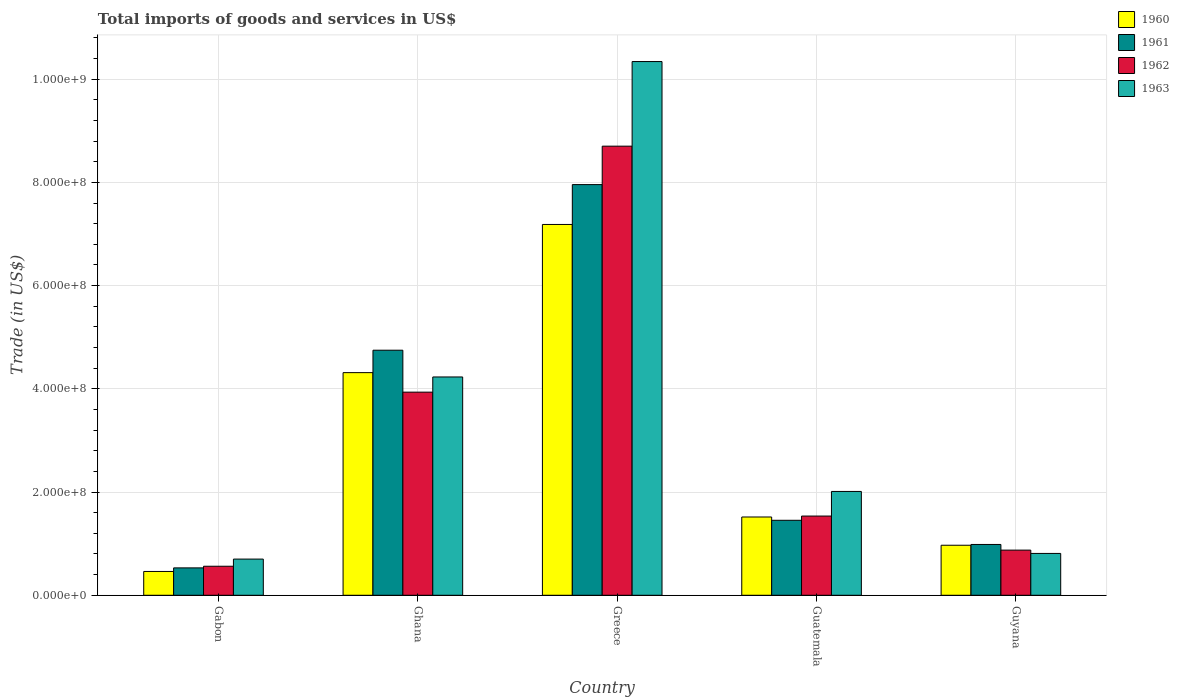Are the number of bars on each tick of the X-axis equal?
Make the answer very short. Yes. How many bars are there on the 1st tick from the left?
Your response must be concise. 4. What is the label of the 1st group of bars from the left?
Give a very brief answer. Gabon. In how many cases, is the number of bars for a given country not equal to the number of legend labels?
Provide a succinct answer. 0. What is the total imports of goods and services in 1960 in Greece?
Your answer should be very brief. 7.19e+08. Across all countries, what is the maximum total imports of goods and services in 1960?
Keep it short and to the point. 7.19e+08. Across all countries, what is the minimum total imports of goods and services in 1961?
Your answer should be very brief. 5.31e+07. In which country was the total imports of goods and services in 1961 minimum?
Keep it short and to the point. Gabon. What is the total total imports of goods and services in 1961 in the graph?
Provide a succinct answer. 1.57e+09. What is the difference between the total imports of goods and services in 1963 in Guatemala and that in Guyana?
Your response must be concise. 1.20e+08. What is the difference between the total imports of goods and services in 1962 in Guatemala and the total imports of goods and services in 1963 in Gabon?
Make the answer very short. 8.34e+07. What is the average total imports of goods and services in 1963 per country?
Your response must be concise. 3.62e+08. What is the difference between the total imports of goods and services of/in 1961 and total imports of goods and services of/in 1962 in Gabon?
Make the answer very short. -3.16e+06. What is the ratio of the total imports of goods and services in 1962 in Greece to that in Guatemala?
Give a very brief answer. 5.67. What is the difference between the highest and the second highest total imports of goods and services in 1960?
Offer a very short reply. -2.80e+08. What is the difference between the highest and the lowest total imports of goods and services in 1962?
Keep it short and to the point. 8.14e+08. Is it the case that in every country, the sum of the total imports of goods and services in 1960 and total imports of goods and services in 1961 is greater than the sum of total imports of goods and services in 1962 and total imports of goods and services in 1963?
Provide a succinct answer. No. What does the 3rd bar from the left in Ghana represents?
Your answer should be very brief. 1962. What does the 3rd bar from the right in Ghana represents?
Provide a succinct answer. 1961. Are all the bars in the graph horizontal?
Give a very brief answer. No. What is the difference between two consecutive major ticks on the Y-axis?
Make the answer very short. 2.00e+08. Does the graph contain any zero values?
Offer a very short reply. No. Where does the legend appear in the graph?
Make the answer very short. Top right. How many legend labels are there?
Provide a short and direct response. 4. How are the legend labels stacked?
Provide a short and direct response. Vertical. What is the title of the graph?
Offer a terse response. Total imports of goods and services in US$. What is the label or title of the X-axis?
Make the answer very short. Country. What is the label or title of the Y-axis?
Offer a terse response. Trade (in US$). What is the Trade (in US$) in 1960 in Gabon?
Give a very brief answer. 4.62e+07. What is the Trade (in US$) of 1961 in Gabon?
Keep it short and to the point. 5.31e+07. What is the Trade (in US$) of 1962 in Gabon?
Keep it short and to the point. 5.62e+07. What is the Trade (in US$) in 1963 in Gabon?
Offer a very short reply. 7.01e+07. What is the Trade (in US$) in 1960 in Ghana?
Offer a very short reply. 4.31e+08. What is the Trade (in US$) in 1961 in Ghana?
Your response must be concise. 4.75e+08. What is the Trade (in US$) of 1962 in Ghana?
Your response must be concise. 3.94e+08. What is the Trade (in US$) of 1963 in Ghana?
Offer a very short reply. 4.23e+08. What is the Trade (in US$) in 1960 in Greece?
Give a very brief answer. 7.19e+08. What is the Trade (in US$) of 1961 in Greece?
Make the answer very short. 7.96e+08. What is the Trade (in US$) of 1962 in Greece?
Offer a terse response. 8.70e+08. What is the Trade (in US$) in 1963 in Greece?
Your answer should be compact. 1.03e+09. What is the Trade (in US$) in 1960 in Guatemala?
Your response must be concise. 1.52e+08. What is the Trade (in US$) of 1961 in Guatemala?
Your response must be concise. 1.45e+08. What is the Trade (in US$) of 1962 in Guatemala?
Provide a succinct answer. 1.54e+08. What is the Trade (in US$) in 1963 in Guatemala?
Your response must be concise. 2.01e+08. What is the Trade (in US$) in 1960 in Guyana?
Provide a short and direct response. 9.69e+07. What is the Trade (in US$) of 1961 in Guyana?
Give a very brief answer. 9.85e+07. What is the Trade (in US$) in 1962 in Guyana?
Make the answer very short. 8.75e+07. What is the Trade (in US$) of 1963 in Guyana?
Give a very brief answer. 8.11e+07. Across all countries, what is the maximum Trade (in US$) of 1960?
Offer a very short reply. 7.19e+08. Across all countries, what is the maximum Trade (in US$) of 1961?
Provide a short and direct response. 7.96e+08. Across all countries, what is the maximum Trade (in US$) in 1962?
Provide a short and direct response. 8.70e+08. Across all countries, what is the maximum Trade (in US$) of 1963?
Keep it short and to the point. 1.03e+09. Across all countries, what is the minimum Trade (in US$) in 1960?
Keep it short and to the point. 4.62e+07. Across all countries, what is the minimum Trade (in US$) of 1961?
Your answer should be compact. 5.31e+07. Across all countries, what is the minimum Trade (in US$) in 1962?
Ensure brevity in your answer.  5.62e+07. Across all countries, what is the minimum Trade (in US$) in 1963?
Your answer should be very brief. 7.01e+07. What is the total Trade (in US$) in 1960 in the graph?
Keep it short and to the point. 1.44e+09. What is the total Trade (in US$) of 1961 in the graph?
Ensure brevity in your answer.  1.57e+09. What is the total Trade (in US$) of 1962 in the graph?
Make the answer very short. 1.56e+09. What is the total Trade (in US$) of 1963 in the graph?
Your answer should be very brief. 1.81e+09. What is the difference between the Trade (in US$) in 1960 in Gabon and that in Ghana?
Your response must be concise. -3.85e+08. What is the difference between the Trade (in US$) of 1961 in Gabon and that in Ghana?
Offer a terse response. -4.22e+08. What is the difference between the Trade (in US$) of 1962 in Gabon and that in Ghana?
Offer a terse response. -3.37e+08. What is the difference between the Trade (in US$) of 1963 in Gabon and that in Ghana?
Keep it short and to the point. -3.53e+08. What is the difference between the Trade (in US$) of 1960 in Gabon and that in Greece?
Provide a short and direct response. -6.72e+08. What is the difference between the Trade (in US$) of 1961 in Gabon and that in Greece?
Your answer should be compact. -7.43e+08. What is the difference between the Trade (in US$) in 1962 in Gabon and that in Greece?
Ensure brevity in your answer.  -8.14e+08. What is the difference between the Trade (in US$) of 1963 in Gabon and that in Greece?
Give a very brief answer. -9.64e+08. What is the difference between the Trade (in US$) of 1960 in Gabon and that in Guatemala?
Provide a succinct answer. -1.06e+08. What is the difference between the Trade (in US$) in 1961 in Gabon and that in Guatemala?
Ensure brevity in your answer.  -9.22e+07. What is the difference between the Trade (in US$) of 1962 in Gabon and that in Guatemala?
Provide a short and direct response. -9.73e+07. What is the difference between the Trade (in US$) in 1963 in Gabon and that in Guatemala?
Your response must be concise. -1.31e+08. What is the difference between the Trade (in US$) of 1960 in Gabon and that in Guyana?
Provide a succinct answer. -5.08e+07. What is the difference between the Trade (in US$) in 1961 in Gabon and that in Guyana?
Keep it short and to the point. -4.54e+07. What is the difference between the Trade (in US$) in 1962 in Gabon and that in Guyana?
Ensure brevity in your answer.  -3.13e+07. What is the difference between the Trade (in US$) of 1963 in Gabon and that in Guyana?
Provide a short and direct response. -1.10e+07. What is the difference between the Trade (in US$) in 1960 in Ghana and that in Greece?
Ensure brevity in your answer.  -2.87e+08. What is the difference between the Trade (in US$) of 1961 in Ghana and that in Greece?
Keep it short and to the point. -3.21e+08. What is the difference between the Trade (in US$) in 1962 in Ghana and that in Greece?
Keep it short and to the point. -4.77e+08. What is the difference between the Trade (in US$) of 1963 in Ghana and that in Greece?
Give a very brief answer. -6.11e+08. What is the difference between the Trade (in US$) in 1960 in Ghana and that in Guatemala?
Ensure brevity in your answer.  2.80e+08. What is the difference between the Trade (in US$) of 1961 in Ghana and that in Guatemala?
Keep it short and to the point. 3.30e+08. What is the difference between the Trade (in US$) in 1962 in Ghana and that in Guatemala?
Give a very brief answer. 2.40e+08. What is the difference between the Trade (in US$) of 1963 in Ghana and that in Guatemala?
Your answer should be compact. 2.22e+08. What is the difference between the Trade (in US$) of 1960 in Ghana and that in Guyana?
Ensure brevity in your answer.  3.34e+08. What is the difference between the Trade (in US$) in 1961 in Ghana and that in Guyana?
Your answer should be compact. 3.76e+08. What is the difference between the Trade (in US$) in 1962 in Ghana and that in Guyana?
Your response must be concise. 3.06e+08. What is the difference between the Trade (in US$) in 1963 in Ghana and that in Guyana?
Your answer should be compact. 3.42e+08. What is the difference between the Trade (in US$) in 1960 in Greece and that in Guatemala?
Your response must be concise. 5.67e+08. What is the difference between the Trade (in US$) of 1961 in Greece and that in Guatemala?
Your answer should be compact. 6.50e+08. What is the difference between the Trade (in US$) in 1962 in Greece and that in Guatemala?
Offer a terse response. 7.17e+08. What is the difference between the Trade (in US$) in 1963 in Greece and that in Guatemala?
Make the answer very short. 8.33e+08. What is the difference between the Trade (in US$) of 1960 in Greece and that in Guyana?
Your answer should be very brief. 6.22e+08. What is the difference between the Trade (in US$) of 1961 in Greece and that in Guyana?
Your response must be concise. 6.97e+08. What is the difference between the Trade (in US$) in 1962 in Greece and that in Guyana?
Your answer should be compact. 7.83e+08. What is the difference between the Trade (in US$) in 1963 in Greece and that in Guyana?
Your answer should be very brief. 9.53e+08. What is the difference between the Trade (in US$) of 1960 in Guatemala and that in Guyana?
Make the answer very short. 5.48e+07. What is the difference between the Trade (in US$) of 1961 in Guatemala and that in Guyana?
Make the answer very short. 4.68e+07. What is the difference between the Trade (in US$) in 1962 in Guatemala and that in Guyana?
Give a very brief answer. 6.60e+07. What is the difference between the Trade (in US$) in 1963 in Guatemala and that in Guyana?
Provide a succinct answer. 1.20e+08. What is the difference between the Trade (in US$) in 1960 in Gabon and the Trade (in US$) in 1961 in Ghana?
Your response must be concise. -4.29e+08. What is the difference between the Trade (in US$) of 1960 in Gabon and the Trade (in US$) of 1962 in Ghana?
Your answer should be compact. -3.47e+08. What is the difference between the Trade (in US$) in 1960 in Gabon and the Trade (in US$) in 1963 in Ghana?
Your answer should be compact. -3.77e+08. What is the difference between the Trade (in US$) of 1961 in Gabon and the Trade (in US$) of 1962 in Ghana?
Your answer should be compact. -3.41e+08. What is the difference between the Trade (in US$) in 1961 in Gabon and the Trade (in US$) in 1963 in Ghana?
Make the answer very short. -3.70e+08. What is the difference between the Trade (in US$) of 1962 in Gabon and the Trade (in US$) of 1963 in Ghana?
Your response must be concise. -3.67e+08. What is the difference between the Trade (in US$) of 1960 in Gabon and the Trade (in US$) of 1961 in Greece?
Offer a very short reply. -7.50e+08. What is the difference between the Trade (in US$) in 1960 in Gabon and the Trade (in US$) in 1962 in Greece?
Offer a terse response. -8.24e+08. What is the difference between the Trade (in US$) of 1960 in Gabon and the Trade (in US$) of 1963 in Greece?
Your response must be concise. -9.88e+08. What is the difference between the Trade (in US$) of 1961 in Gabon and the Trade (in US$) of 1962 in Greece?
Give a very brief answer. -8.17e+08. What is the difference between the Trade (in US$) of 1961 in Gabon and the Trade (in US$) of 1963 in Greece?
Your answer should be compact. -9.81e+08. What is the difference between the Trade (in US$) of 1962 in Gabon and the Trade (in US$) of 1963 in Greece?
Provide a succinct answer. -9.78e+08. What is the difference between the Trade (in US$) in 1960 in Gabon and the Trade (in US$) in 1961 in Guatemala?
Keep it short and to the point. -9.91e+07. What is the difference between the Trade (in US$) of 1960 in Gabon and the Trade (in US$) of 1962 in Guatemala?
Your answer should be compact. -1.07e+08. What is the difference between the Trade (in US$) of 1960 in Gabon and the Trade (in US$) of 1963 in Guatemala?
Keep it short and to the point. -1.55e+08. What is the difference between the Trade (in US$) of 1961 in Gabon and the Trade (in US$) of 1962 in Guatemala?
Provide a succinct answer. -1.00e+08. What is the difference between the Trade (in US$) of 1961 in Gabon and the Trade (in US$) of 1963 in Guatemala?
Provide a short and direct response. -1.48e+08. What is the difference between the Trade (in US$) in 1962 in Gabon and the Trade (in US$) in 1963 in Guatemala?
Offer a terse response. -1.45e+08. What is the difference between the Trade (in US$) of 1960 in Gabon and the Trade (in US$) of 1961 in Guyana?
Ensure brevity in your answer.  -5.23e+07. What is the difference between the Trade (in US$) in 1960 in Gabon and the Trade (in US$) in 1962 in Guyana?
Provide a short and direct response. -4.13e+07. What is the difference between the Trade (in US$) in 1960 in Gabon and the Trade (in US$) in 1963 in Guyana?
Make the answer very short. -3.49e+07. What is the difference between the Trade (in US$) in 1961 in Gabon and the Trade (in US$) in 1962 in Guyana?
Your response must be concise. -3.44e+07. What is the difference between the Trade (in US$) in 1961 in Gabon and the Trade (in US$) in 1963 in Guyana?
Keep it short and to the point. -2.80e+07. What is the difference between the Trade (in US$) of 1962 in Gabon and the Trade (in US$) of 1963 in Guyana?
Your answer should be very brief. -2.48e+07. What is the difference between the Trade (in US$) of 1960 in Ghana and the Trade (in US$) of 1961 in Greece?
Provide a short and direct response. -3.64e+08. What is the difference between the Trade (in US$) in 1960 in Ghana and the Trade (in US$) in 1962 in Greece?
Ensure brevity in your answer.  -4.39e+08. What is the difference between the Trade (in US$) of 1960 in Ghana and the Trade (in US$) of 1963 in Greece?
Give a very brief answer. -6.03e+08. What is the difference between the Trade (in US$) of 1961 in Ghana and the Trade (in US$) of 1962 in Greece?
Make the answer very short. -3.95e+08. What is the difference between the Trade (in US$) of 1961 in Ghana and the Trade (in US$) of 1963 in Greece?
Your answer should be compact. -5.59e+08. What is the difference between the Trade (in US$) of 1962 in Ghana and the Trade (in US$) of 1963 in Greece?
Offer a very short reply. -6.41e+08. What is the difference between the Trade (in US$) of 1960 in Ghana and the Trade (in US$) of 1961 in Guatemala?
Provide a succinct answer. 2.86e+08. What is the difference between the Trade (in US$) of 1960 in Ghana and the Trade (in US$) of 1962 in Guatemala?
Offer a terse response. 2.78e+08. What is the difference between the Trade (in US$) of 1960 in Ghana and the Trade (in US$) of 1963 in Guatemala?
Make the answer very short. 2.30e+08. What is the difference between the Trade (in US$) in 1961 in Ghana and the Trade (in US$) in 1962 in Guatemala?
Offer a terse response. 3.21e+08. What is the difference between the Trade (in US$) in 1961 in Ghana and the Trade (in US$) in 1963 in Guatemala?
Ensure brevity in your answer.  2.74e+08. What is the difference between the Trade (in US$) in 1962 in Ghana and the Trade (in US$) in 1963 in Guatemala?
Ensure brevity in your answer.  1.92e+08. What is the difference between the Trade (in US$) of 1960 in Ghana and the Trade (in US$) of 1961 in Guyana?
Your answer should be compact. 3.33e+08. What is the difference between the Trade (in US$) of 1960 in Ghana and the Trade (in US$) of 1962 in Guyana?
Make the answer very short. 3.44e+08. What is the difference between the Trade (in US$) in 1960 in Ghana and the Trade (in US$) in 1963 in Guyana?
Provide a succinct answer. 3.50e+08. What is the difference between the Trade (in US$) in 1961 in Ghana and the Trade (in US$) in 1962 in Guyana?
Make the answer very short. 3.87e+08. What is the difference between the Trade (in US$) of 1961 in Ghana and the Trade (in US$) of 1963 in Guyana?
Your response must be concise. 3.94e+08. What is the difference between the Trade (in US$) in 1962 in Ghana and the Trade (in US$) in 1963 in Guyana?
Your answer should be very brief. 3.13e+08. What is the difference between the Trade (in US$) of 1960 in Greece and the Trade (in US$) of 1961 in Guatemala?
Your answer should be very brief. 5.73e+08. What is the difference between the Trade (in US$) of 1960 in Greece and the Trade (in US$) of 1962 in Guatemala?
Your response must be concise. 5.65e+08. What is the difference between the Trade (in US$) of 1960 in Greece and the Trade (in US$) of 1963 in Guatemala?
Provide a succinct answer. 5.17e+08. What is the difference between the Trade (in US$) of 1961 in Greece and the Trade (in US$) of 1962 in Guatemala?
Provide a short and direct response. 6.42e+08. What is the difference between the Trade (in US$) in 1961 in Greece and the Trade (in US$) in 1963 in Guatemala?
Offer a terse response. 5.95e+08. What is the difference between the Trade (in US$) of 1962 in Greece and the Trade (in US$) of 1963 in Guatemala?
Your answer should be compact. 6.69e+08. What is the difference between the Trade (in US$) in 1960 in Greece and the Trade (in US$) in 1961 in Guyana?
Your answer should be very brief. 6.20e+08. What is the difference between the Trade (in US$) of 1960 in Greece and the Trade (in US$) of 1962 in Guyana?
Your answer should be compact. 6.31e+08. What is the difference between the Trade (in US$) of 1960 in Greece and the Trade (in US$) of 1963 in Guyana?
Provide a short and direct response. 6.37e+08. What is the difference between the Trade (in US$) of 1961 in Greece and the Trade (in US$) of 1962 in Guyana?
Ensure brevity in your answer.  7.08e+08. What is the difference between the Trade (in US$) in 1961 in Greece and the Trade (in US$) in 1963 in Guyana?
Give a very brief answer. 7.15e+08. What is the difference between the Trade (in US$) in 1962 in Greece and the Trade (in US$) in 1963 in Guyana?
Ensure brevity in your answer.  7.89e+08. What is the difference between the Trade (in US$) of 1960 in Guatemala and the Trade (in US$) of 1961 in Guyana?
Make the answer very short. 5.32e+07. What is the difference between the Trade (in US$) of 1960 in Guatemala and the Trade (in US$) of 1962 in Guyana?
Your response must be concise. 6.42e+07. What is the difference between the Trade (in US$) of 1960 in Guatemala and the Trade (in US$) of 1963 in Guyana?
Offer a very short reply. 7.06e+07. What is the difference between the Trade (in US$) of 1961 in Guatemala and the Trade (in US$) of 1962 in Guyana?
Provide a short and direct response. 5.78e+07. What is the difference between the Trade (in US$) in 1961 in Guatemala and the Trade (in US$) in 1963 in Guyana?
Provide a short and direct response. 6.42e+07. What is the difference between the Trade (in US$) of 1962 in Guatemala and the Trade (in US$) of 1963 in Guyana?
Your answer should be very brief. 7.24e+07. What is the average Trade (in US$) of 1960 per country?
Provide a short and direct response. 2.89e+08. What is the average Trade (in US$) of 1961 per country?
Your answer should be compact. 3.13e+08. What is the average Trade (in US$) of 1962 per country?
Offer a very short reply. 3.12e+08. What is the average Trade (in US$) in 1963 per country?
Offer a very short reply. 3.62e+08. What is the difference between the Trade (in US$) in 1960 and Trade (in US$) in 1961 in Gabon?
Provide a succinct answer. -6.92e+06. What is the difference between the Trade (in US$) in 1960 and Trade (in US$) in 1962 in Gabon?
Your answer should be very brief. -1.01e+07. What is the difference between the Trade (in US$) in 1960 and Trade (in US$) in 1963 in Gabon?
Your answer should be very brief. -2.40e+07. What is the difference between the Trade (in US$) of 1961 and Trade (in US$) of 1962 in Gabon?
Offer a very short reply. -3.16e+06. What is the difference between the Trade (in US$) in 1961 and Trade (in US$) in 1963 in Gabon?
Ensure brevity in your answer.  -1.70e+07. What is the difference between the Trade (in US$) in 1962 and Trade (in US$) in 1963 in Gabon?
Provide a succinct answer. -1.39e+07. What is the difference between the Trade (in US$) of 1960 and Trade (in US$) of 1961 in Ghana?
Offer a terse response. -4.34e+07. What is the difference between the Trade (in US$) of 1960 and Trade (in US$) of 1962 in Ghana?
Offer a very short reply. 3.78e+07. What is the difference between the Trade (in US$) of 1960 and Trade (in US$) of 1963 in Ghana?
Ensure brevity in your answer.  8.40e+06. What is the difference between the Trade (in US$) of 1961 and Trade (in US$) of 1962 in Ghana?
Provide a succinct answer. 8.12e+07. What is the difference between the Trade (in US$) of 1961 and Trade (in US$) of 1963 in Ghana?
Offer a very short reply. 5.18e+07. What is the difference between the Trade (in US$) of 1962 and Trade (in US$) of 1963 in Ghana?
Your response must be concise. -2.94e+07. What is the difference between the Trade (in US$) in 1960 and Trade (in US$) in 1961 in Greece?
Your response must be concise. -7.72e+07. What is the difference between the Trade (in US$) in 1960 and Trade (in US$) in 1962 in Greece?
Your answer should be very brief. -1.52e+08. What is the difference between the Trade (in US$) of 1960 and Trade (in US$) of 1963 in Greece?
Your answer should be compact. -3.16e+08. What is the difference between the Trade (in US$) of 1961 and Trade (in US$) of 1962 in Greece?
Your answer should be compact. -7.45e+07. What is the difference between the Trade (in US$) in 1961 and Trade (in US$) in 1963 in Greece?
Offer a very short reply. -2.38e+08. What is the difference between the Trade (in US$) in 1962 and Trade (in US$) in 1963 in Greece?
Give a very brief answer. -1.64e+08. What is the difference between the Trade (in US$) in 1960 and Trade (in US$) in 1961 in Guatemala?
Offer a terse response. 6.40e+06. What is the difference between the Trade (in US$) of 1960 and Trade (in US$) of 1962 in Guatemala?
Ensure brevity in your answer.  -1.80e+06. What is the difference between the Trade (in US$) in 1960 and Trade (in US$) in 1963 in Guatemala?
Your response must be concise. -4.95e+07. What is the difference between the Trade (in US$) of 1961 and Trade (in US$) of 1962 in Guatemala?
Offer a very short reply. -8.20e+06. What is the difference between the Trade (in US$) of 1961 and Trade (in US$) of 1963 in Guatemala?
Give a very brief answer. -5.59e+07. What is the difference between the Trade (in US$) in 1962 and Trade (in US$) in 1963 in Guatemala?
Your answer should be very brief. -4.77e+07. What is the difference between the Trade (in US$) in 1960 and Trade (in US$) in 1961 in Guyana?
Provide a succinct answer. -1.52e+06. What is the difference between the Trade (in US$) in 1960 and Trade (in US$) in 1962 in Guyana?
Your answer should be compact. 9.45e+06. What is the difference between the Trade (in US$) of 1960 and Trade (in US$) of 1963 in Guyana?
Provide a short and direct response. 1.59e+07. What is the difference between the Trade (in US$) of 1961 and Trade (in US$) of 1962 in Guyana?
Make the answer very short. 1.10e+07. What is the difference between the Trade (in US$) of 1961 and Trade (in US$) of 1963 in Guyana?
Provide a succinct answer. 1.74e+07. What is the difference between the Trade (in US$) of 1962 and Trade (in US$) of 1963 in Guyana?
Offer a very short reply. 6.42e+06. What is the ratio of the Trade (in US$) in 1960 in Gabon to that in Ghana?
Offer a terse response. 0.11. What is the ratio of the Trade (in US$) in 1961 in Gabon to that in Ghana?
Your answer should be compact. 0.11. What is the ratio of the Trade (in US$) of 1962 in Gabon to that in Ghana?
Your answer should be very brief. 0.14. What is the ratio of the Trade (in US$) of 1963 in Gabon to that in Ghana?
Keep it short and to the point. 0.17. What is the ratio of the Trade (in US$) of 1960 in Gabon to that in Greece?
Give a very brief answer. 0.06. What is the ratio of the Trade (in US$) of 1961 in Gabon to that in Greece?
Offer a terse response. 0.07. What is the ratio of the Trade (in US$) of 1962 in Gabon to that in Greece?
Provide a short and direct response. 0.06. What is the ratio of the Trade (in US$) in 1963 in Gabon to that in Greece?
Your answer should be very brief. 0.07. What is the ratio of the Trade (in US$) of 1960 in Gabon to that in Guatemala?
Offer a terse response. 0.3. What is the ratio of the Trade (in US$) in 1961 in Gabon to that in Guatemala?
Offer a very short reply. 0.37. What is the ratio of the Trade (in US$) in 1962 in Gabon to that in Guatemala?
Provide a succinct answer. 0.37. What is the ratio of the Trade (in US$) of 1963 in Gabon to that in Guatemala?
Provide a short and direct response. 0.35. What is the ratio of the Trade (in US$) in 1960 in Gabon to that in Guyana?
Your answer should be compact. 0.48. What is the ratio of the Trade (in US$) in 1961 in Gabon to that in Guyana?
Ensure brevity in your answer.  0.54. What is the ratio of the Trade (in US$) of 1962 in Gabon to that in Guyana?
Make the answer very short. 0.64. What is the ratio of the Trade (in US$) in 1963 in Gabon to that in Guyana?
Make the answer very short. 0.86. What is the ratio of the Trade (in US$) in 1960 in Ghana to that in Greece?
Offer a very short reply. 0.6. What is the ratio of the Trade (in US$) in 1961 in Ghana to that in Greece?
Your answer should be very brief. 0.6. What is the ratio of the Trade (in US$) of 1962 in Ghana to that in Greece?
Your answer should be compact. 0.45. What is the ratio of the Trade (in US$) of 1963 in Ghana to that in Greece?
Offer a terse response. 0.41. What is the ratio of the Trade (in US$) in 1960 in Ghana to that in Guatemala?
Your response must be concise. 2.84. What is the ratio of the Trade (in US$) in 1961 in Ghana to that in Guatemala?
Your answer should be very brief. 3.27. What is the ratio of the Trade (in US$) of 1962 in Ghana to that in Guatemala?
Provide a succinct answer. 2.56. What is the ratio of the Trade (in US$) of 1963 in Ghana to that in Guatemala?
Your response must be concise. 2.1. What is the ratio of the Trade (in US$) of 1960 in Ghana to that in Guyana?
Provide a succinct answer. 4.45. What is the ratio of the Trade (in US$) in 1961 in Ghana to that in Guyana?
Your answer should be very brief. 4.82. What is the ratio of the Trade (in US$) in 1962 in Ghana to that in Guyana?
Provide a succinct answer. 4.5. What is the ratio of the Trade (in US$) in 1963 in Ghana to that in Guyana?
Your answer should be compact. 5.22. What is the ratio of the Trade (in US$) of 1960 in Greece to that in Guatemala?
Provide a succinct answer. 4.74. What is the ratio of the Trade (in US$) in 1961 in Greece to that in Guatemala?
Offer a terse response. 5.48. What is the ratio of the Trade (in US$) of 1962 in Greece to that in Guatemala?
Keep it short and to the point. 5.67. What is the ratio of the Trade (in US$) in 1963 in Greece to that in Guatemala?
Your answer should be compact. 5.14. What is the ratio of the Trade (in US$) of 1960 in Greece to that in Guyana?
Give a very brief answer. 7.41. What is the ratio of the Trade (in US$) in 1961 in Greece to that in Guyana?
Make the answer very short. 8.08. What is the ratio of the Trade (in US$) in 1962 in Greece to that in Guyana?
Make the answer very short. 9.95. What is the ratio of the Trade (in US$) in 1963 in Greece to that in Guyana?
Offer a terse response. 12.75. What is the ratio of the Trade (in US$) in 1960 in Guatemala to that in Guyana?
Provide a short and direct response. 1.56. What is the ratio of the Trade (in US$) in 1961 in Guatemala to that in Guyana?
Provide a succinct answer. 1.48. What is the ratio of the Trade (in US$) of 1962 in Guatemala to that in Guyana?
Provide a short and direct response. 1.75. What is the ratio of the Trade (in US$) in 1963 in Guatemala to that in Guyana?
Offer a terse response. 2.48. What is the difference between the highest and the second highest Trade (in US$) of 1960?
Give a very brief answer. 2.87e+08. What is the difference between the highest and the second highest Trade (in US$) of 1961?
Your answer should be compact. 3.21e+08. What is the difference between the highest and the second highest Trade (in US$) in 1962?
Provide a short and direct response. 4.77e+08. What is the difference between the highest and the second highest Trade (in US$) of 1963?
Your answer should be very brief. 6.11e+08. What is the difference between the highest and the lowest Trade (in US$) in 1960?
Provide a short and direct response. 6.72e+08. What is the difference between the highest and the lowest Trade (in US$) in 1961?
Offer a terse response. 7.43e+08. What is the difference between the highest and the lowest Trade (in US$) in 1962?
Provide a short and direct response. 8.14e+08. What is the difference between the highest and the lowest Trade (in US$) in 1963?
Your response must be concise. 9.64e+08. 